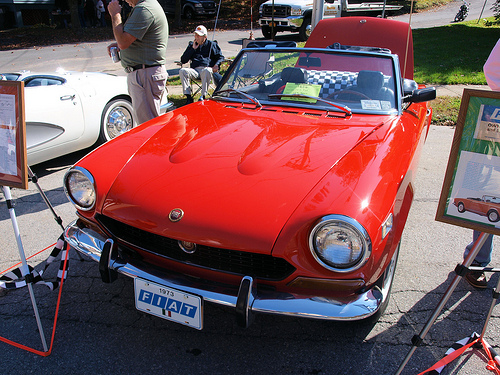<image>
Is the car behind the grass? No. The car is not behind the grass. From this viewpoint, the car appears to be positioned elsewhere in the scene. 